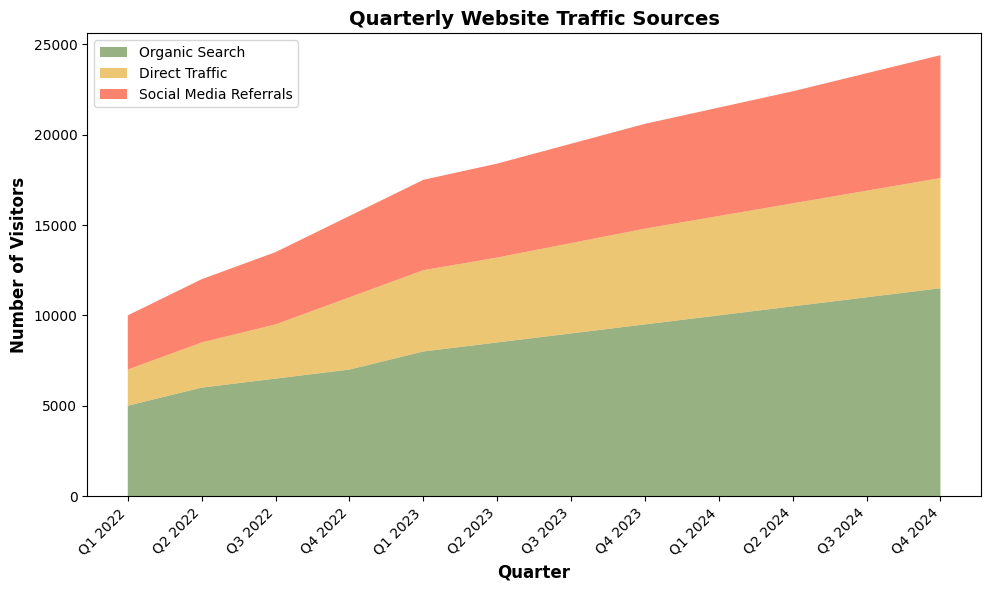What is the overall trend of Organic Search traffic from Q1 2022 to Q4 2024? The Organic Search traffic shows a consistent upward trend from Q1 2022 (5000 visitors) to Q4 2024 (11500 visitors). Each quarter, the number of visitors increases, indicating continuous growth in organic search traffic.
Answer: Consistently upward How does the number of Social Media Referrals in Q4 2023 compare to Q4 2022? The number of Social Media Referrals in Q4 2023 is 5800 visitors, whereas in Q4 2022, it is 4500 visitors. The count in Q4 2023 is noticeably higher, showing an increase of 1300 visitors.
Answer: Increased by 1300 Which quarter has the highest combined website traffic from all sources? To find the quarter with the highest combined traffic, sum the visitors from Organic Search, Direct Traffic, and Social Media Referrals for each quarter. Q4 2024 has the highest combined traffic with 11500 (Organic) + 6100 (Direct) + 6800 (Social Media) = 24400 visitors.
Answer: Q4 2024 Compare the growth rate of Direct Traffic between Q1 2022 to Q1 2023 versus Q1 2023 to Q1 2024. From Q1 2022 to Q1 2023, Direct Traffic grows from 2000 to 4500, an increase of 2500 visitors. From Q1 2023 to Q1 2024, it grows from 4500 to 5500, an increase of 1000 visitors. The growth rate is higher from Q1 2022 to Q1 2023.
Answer: Higher from Q1 2022 to Q1 2023 What is the total increase in visitors from Organic Search from the beginning to the end of the period shown? The total increase is the difference between the number of Organic Search visitors in Q4 2024 (11500) and Q1 2022 (5000). So, the total increase is 11500 - 5000 = 6500 visitors.
Answer: 6500 visitors In which quarter did Social Media Referrals see the greatest increase from the previous quarter? To determine this, calculate the increase in Social Media Referrals for each quarter: 
Q2 2022: 3500 - 3000 = 500, 
Q3 2022: 4000 - 3500 = 500, 
Q4 2022: 4500 - 4000 = 500, 
Q1 2023: 5000 - 4500 = 500, 
Q2 2023: 5200 - 5000 = 200, 
Q3 2023: 5500 - 5200 = 300, 
Q4 2023: 5800 - 5500 = 300,
Q1 2024: 6000 - 5800 = 200,
Q2 2024: 6200 - 6000 = 200, 
Q3 2024: 6500 - 6200 = 300, 
Q4 2024: 6800 - 6500 = 300. 
Each quarter from Q2 2022 to Q1 2023 has the greatest increase of 500.
Answer: Q2, Q3, Q4 2022, and Q1 2023 (each 500 increase) What percentage of total Q1 2024 traffic comes from Organic Search? Total traffic in Q1 2024 is 10000 (Organic) + 5500 (Direct) + 6000 (Social Media) = 21500. The percentage from Organic Search is (10000 / 21500) * 100 ≈ 46.51%.
Answer: ≈ 46.51% Between which two consecutive quarters did Direct Traffic show the smallest increase? Calculate the increase for each consecutive quarter:
Q2 2022: 2500 - 2000 = 500,
Q3 2022: 3000 - 2500 = 500,
Q4 2022: 4000 - 3000 = 1000,
Q1 2023: 4500 - 4000 = 500,
Q2 2023: 4700 - 4500 = 200,
Q3 2023: 5000 - 4700 = 300,
Q4 2023: 5300 - 5000 = 300,
Q1 2024: 5500 - 5300 = 200,
Q2 2024: 5700 - 5500 = 200,
Q3 2024: 5900 - 5700 = 200,
Q4 2024: 6100 - 5900 = 200. 
The smallest increase is 200, occurring between Q1-Q2 2023, Q1-Q2 2024, Q2-Q3 2024, and Q3-Q4 2024.
Answer: Q1-Q2 2023, Q1-Q2 2024, Q2-Q3 2024, and Q3-Q4 2024 By how much did Social Media Referrals increase from the first quarter of the data to the last quarter? Social Media Referrals in Q1 2022 are 3000 and in Q4 2024 are 6800. The increase is 6800 - 3000 = 3800 visitors.
Answer: 3800 visitors 